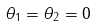<formula> <loc_0><loc_0><loc_500><loc_500>\theta _ { 1 } = \theta _ { 2 } = 0</formula> 